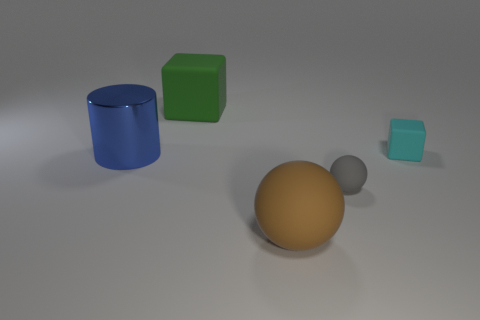Does the green thing have the same shape as the cyan thing?
Give a very brief answer. Yes. Is there anything else that is the same shape as the shiny thing?
Your answer should be compact. No. Is there a big blue cylinder that is in front of the large rubber object in front of the small cube?
Offer a terse response. No. How many other things are there of the same material as the blue thing?
Provide a succinct answer. 0. There is a large matte thing to the right of the big green rubber thing; does it have the same shape as the tiny object that is in front of the shiny thing?
Your answer should be compact. Yes. Does the cyan object have the same material as the cylinder?
Your answer should be compact. No. How big is the cube behind the matte block in front of the large rubber object behind the big blue thing?
Provide a short and direct response. Large. What is the shape of the brown rubber object that is the same size as the blue cylinder?
Your answer should be compact. Sphere. What number of tiny objects are either gray matte balls or blue spheres?
Your answer should be very brief. 1. There is a tiny object in front of the matte thing right of the gray ball; are there any big objects to the left of it?
Offer a very short reply. Yes. 